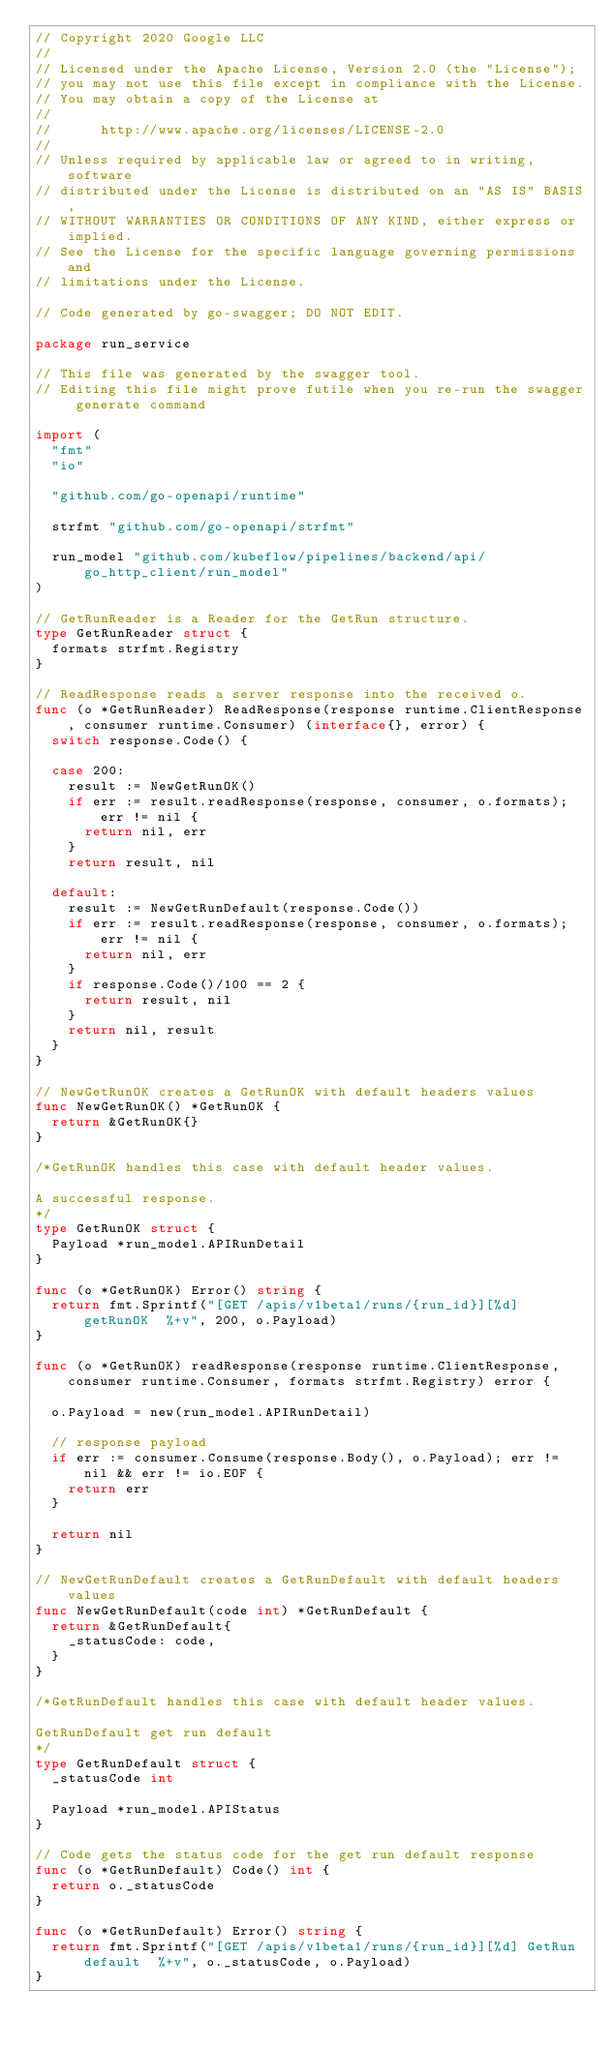<code> <loc_0><loc_0><loc_500><loc_500><_Go_>// Copyright 2020 Google LLC
//
// Licensed under the Apache License, Version 2.0 (the "License");
// you may not use this file except in compliance with the License.
// You may obtain a copy of the License at
//
//      http://www.apache.org/licenses/LICENSE-2.0
//
// Unless required by applicable law or agreed to in writing, software
// distributed under the License is distributed on an "AS IS" BASIS,
// WITHOUT WARRANTIES OR CONDITIONS OF ANY KIND, either express or implied.
// See the License for the specific language governing permissions and
// limitations under the License.

// Code generated by go-swagger; DO NOT EDIT.

package run_service

// This file was generated by the swagger tool.
// Editing this file might prove futile when you re-run the swagger generate command

import (
	"fmt"
	"io"

	"github.com/go-openapi/runtime"

	strfmt "github.com/go-openapi/strfmt"

	run_model "github.com/kubeflow/pipelines/backend/api/go_http_client/run_model"
)

// GetRunReader is a Reader for the GetRun structure.
type GetRunReader struct {
	formats strfmt.Registry
}

// ReadResponse reads a server response into the received o.
func (o *GetRunReader) ReadResponse(response runtime.ClientResponse, consumer runtime.Consumer) (interface{}, error) {
	switch response.Code() {

	case 200:
		result := NewGetRunOK()
		if err := result.readResponse(response, consumer, o.formats); err != nil {
			return nil, err
		}
		return result, nil

	default:
		result := NewGetRunDefault(response.Code())
		if err := result.readResponse(response, consumer, o.formats); err != nil {
			return nil, err
		}
		if response.Code()/100 == 2 {
			return result, nil
		}
		return nil, result
	}
}

// NewGetRunOK creates a GetRunOK with default headers values
func NewGetRunOK() *GetRunOK {
	return &GetRunOK{}
}

/*GetRunOK handles this case with default header values.

A successful response.
*/
type GetRunOK struct {
	Payload *run_model.APIRunDetail
}

func (o *GetRunOK) Error() string {
	return fmt.Sprintf("[GET /apis/v1beta1/runs/{run_id}][%d] getRunOK  %+v", 200, o.Payload)
}

func (o *GetRunOK) readResponse(response runtime.ClientResponse, consumer runtime.Consumer, formats strfmt.Registry) error {

	o.Payload = new(run_model.APIRunDetail)

	// response payload
	if err := consumer.Consume(response.Body(), o.Payload); err != nil && err != io.EOF {
		return err
	}

	return nil
}

// NewGetRunDefault creates a GetRunDefault with default headers values
func NewGetRunDefault(code int) *GetRunDefault {
	return &GetRunDefault{
		_statusCode: code,
	}
}

/*GetRunDefault handles this case with default header values.

GetRunDefault get run default
*/
type GetRunDefault struct {
	_statusCode int

	Payload *run_model.APIStatus
}

// Code gets the status code for the get run default response
func (o *GetRunDefault) Code() int {
	return o._statusCode
}

func (o *GetRunDefault) Error() string {
	return fmt.Sprintf("[GET /apis/v1beta1/runs/{run_id}][%d] GetRun default  %+v", o._statusCode, o.Payload)
}
</code> 